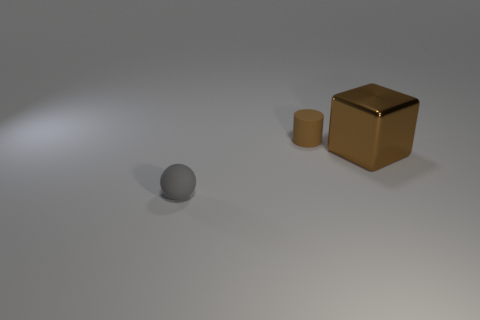Add 1 tiny rubber cylinders. How many objects exist? 4 Subtract all blocks. How many objects are left? 2 Subtract all brown matte cylinders. Subtract all big brown things. How many objects are left? 1 Add 3 small brown things. How many small brown things are left? 4 Add 2 matte objects. How many matte objects exist? 4 Subtract 1 gray balls. How many objects are left? 2 